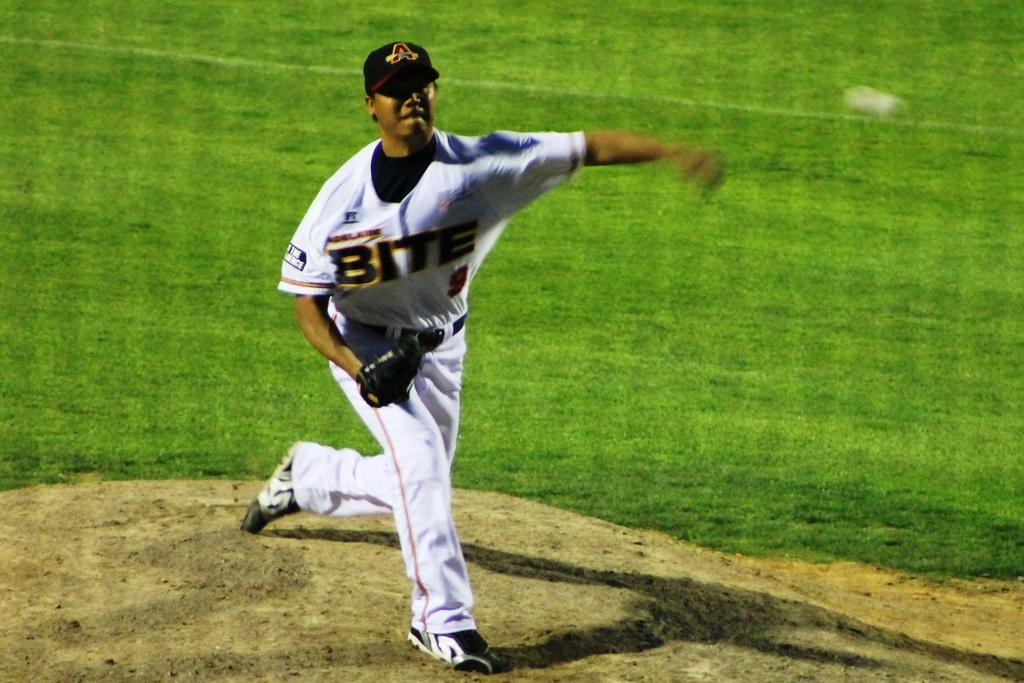<image>
Provide a brief description of the given image. Pitcher for team BITE pitches the ball from the mound. 